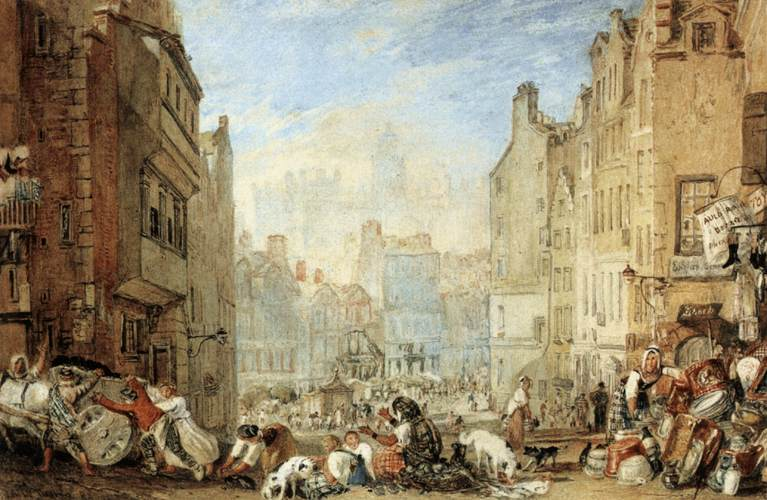Analyze the role of lighting and color in this painting. The lighting and color in the painting play critical roles in establishing both the time of day and the overall mood. The light appears to be midday, as evidenced by the shadow sizes and the bright areas on the buildings and streets. The use of warm earth tones mixed with the soft blues of the sky creates a harmonious and somewhat idealized portrayal of urban life. These color choices make the scene look inviting and vibrant, despite the buzy undertones of the activities being depicted. 